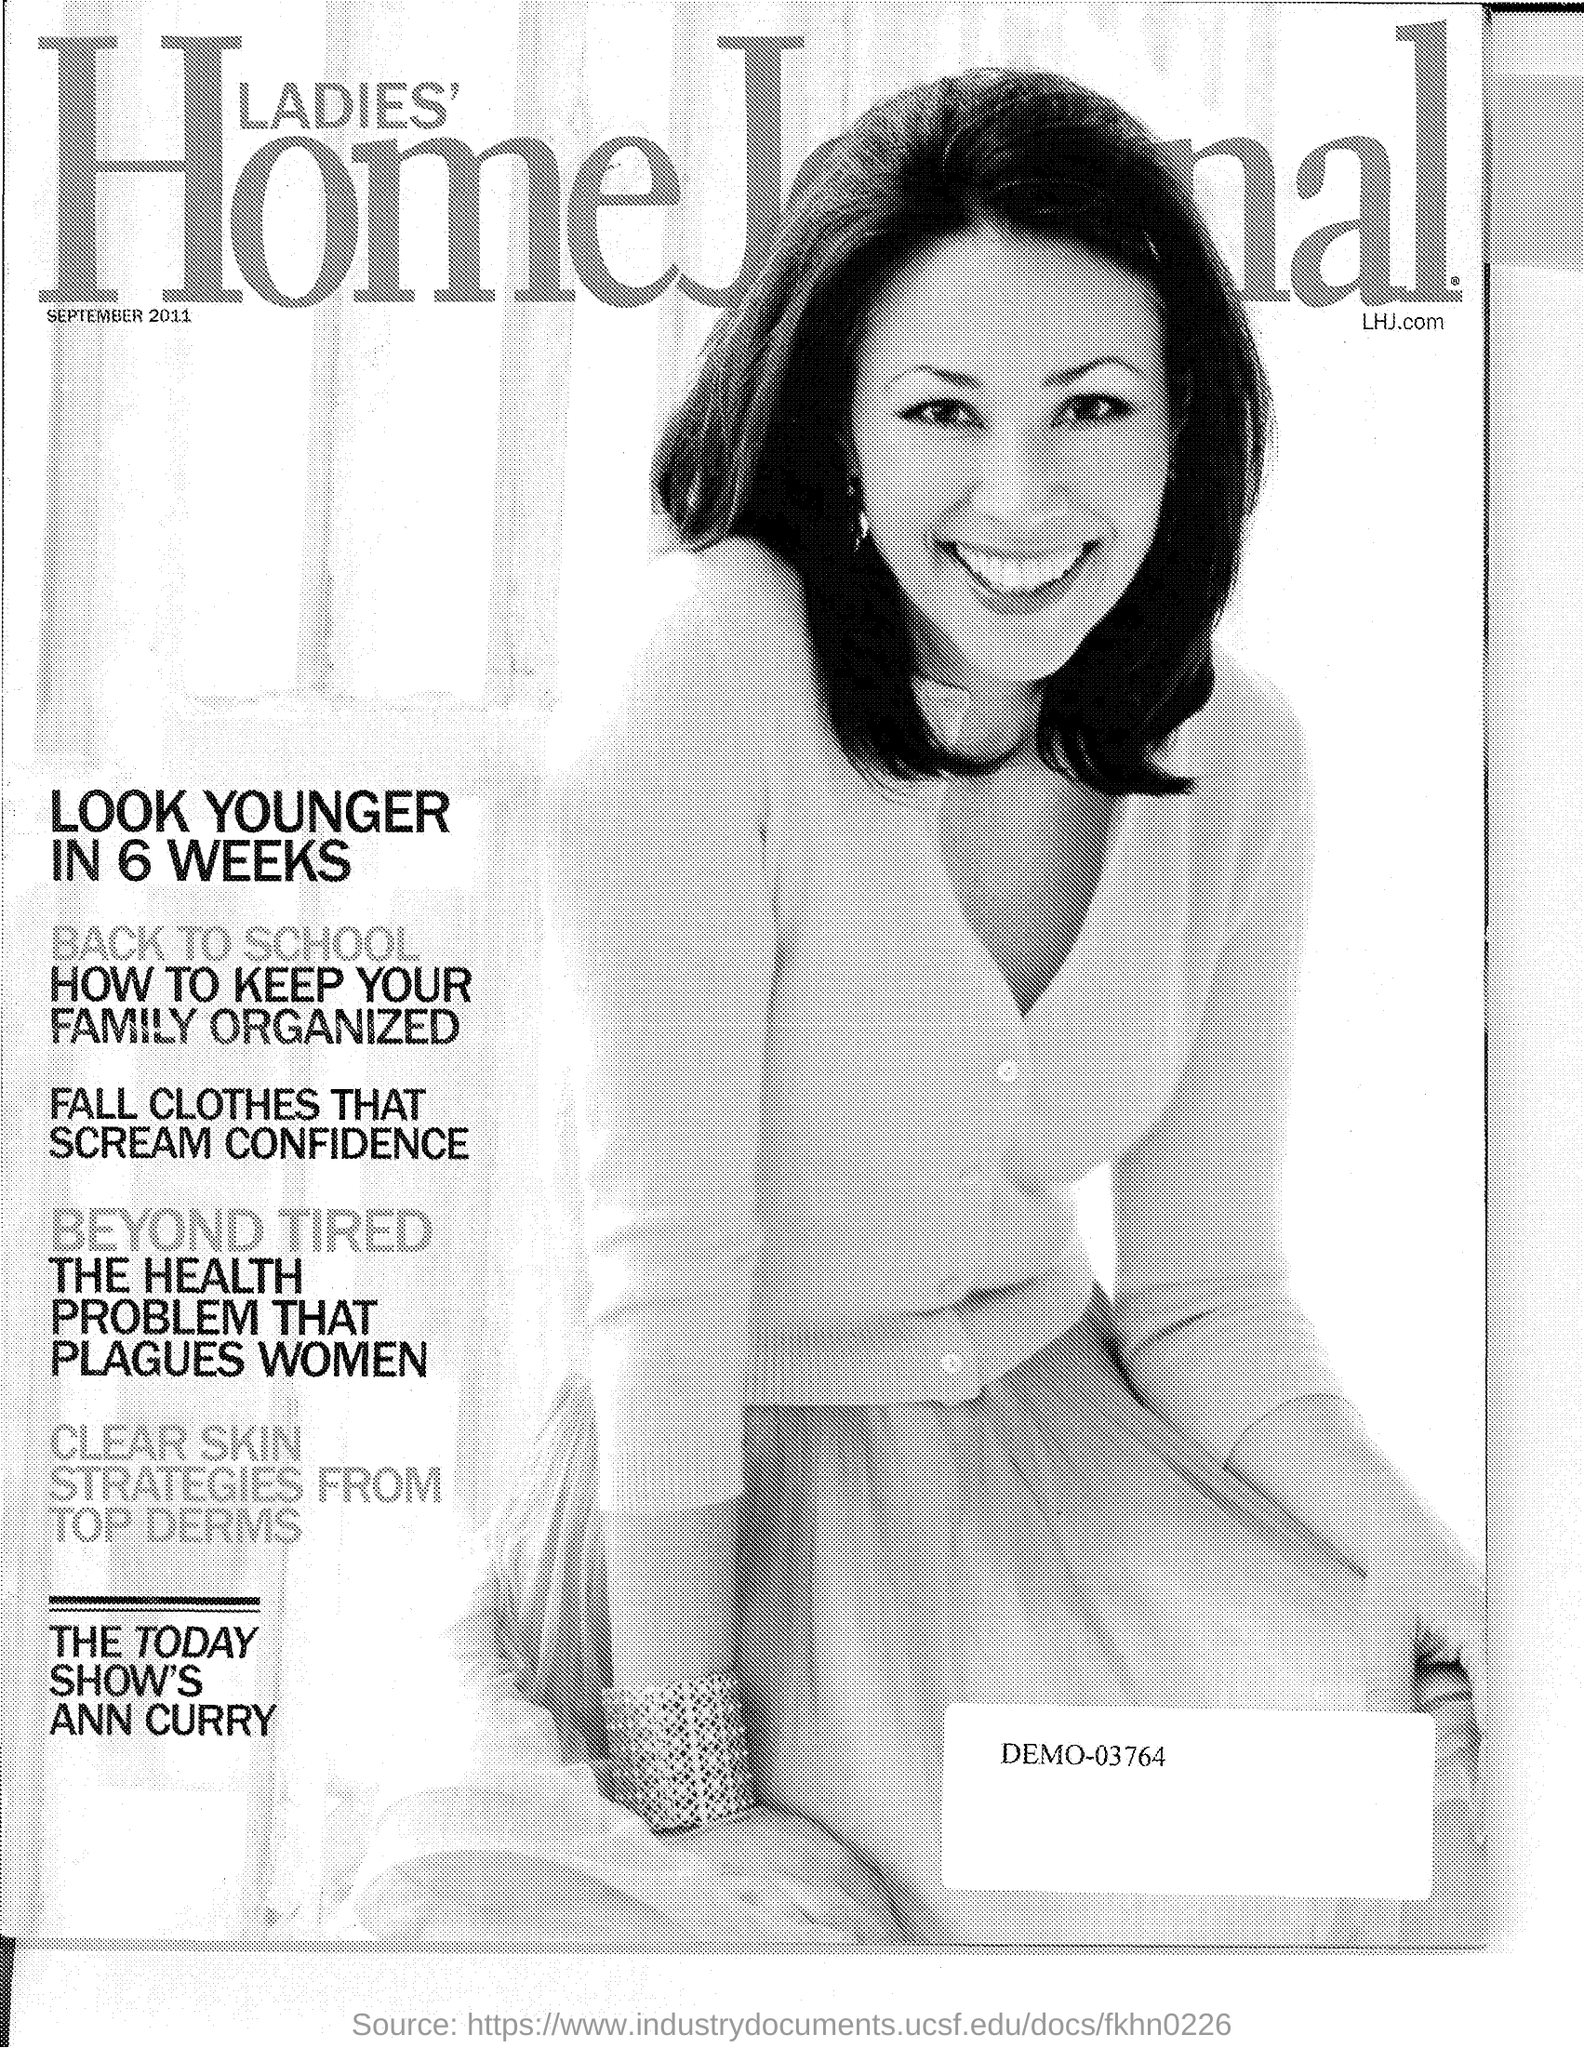What is the year Mentioned in the document?
Offer a very short reply. 2011. 